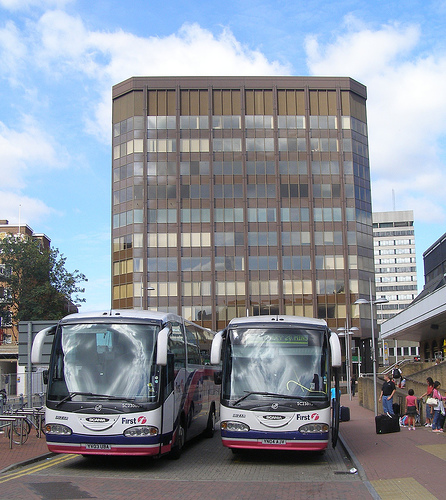Do you see cars or mirrors in this picture? Yes, there are cars visible in the background behind the buses and potentially reflective surfaces on the vehicles that may appear as mirrors. 